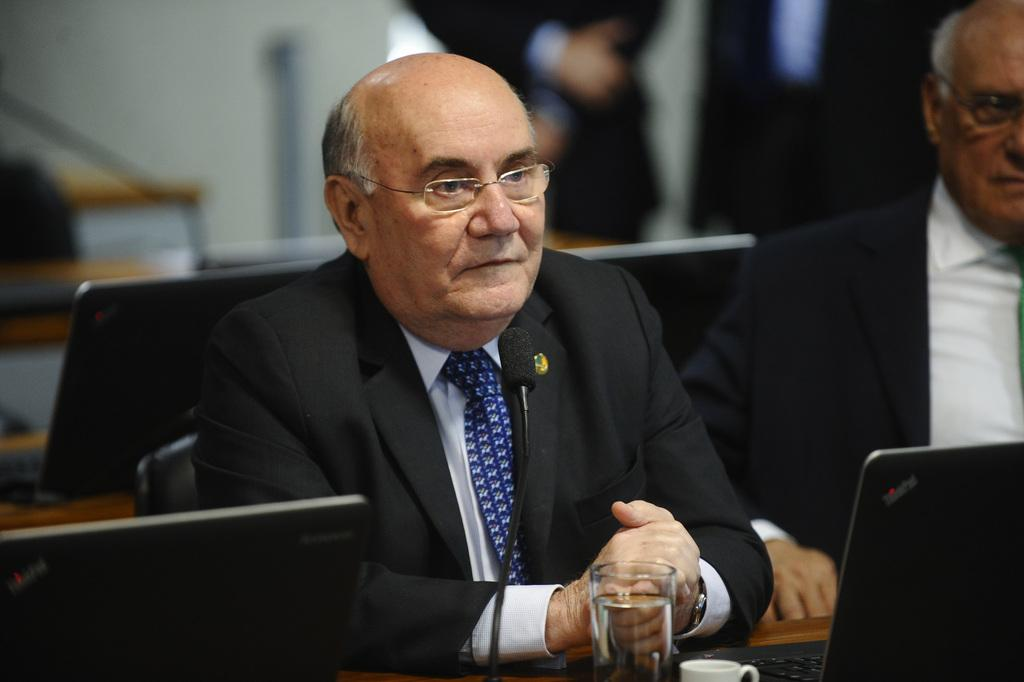How many men are present in the image? There are two men sitting in the image. What are the men wearing? The men are wearing clothes and spectacles. What objects can be seen on the desk in the image? There are systems, a glass, and a tea cup visible on the desk in the image. What is the background of the image like? The background of the image is blurred. What type of floor can be seen in the image? There is no floor visible in the image; it only shows the two men, the desk, and the background. What fact can be learned about the men's rest habits from the image? The image does not provide any information about the men's rest habits. 